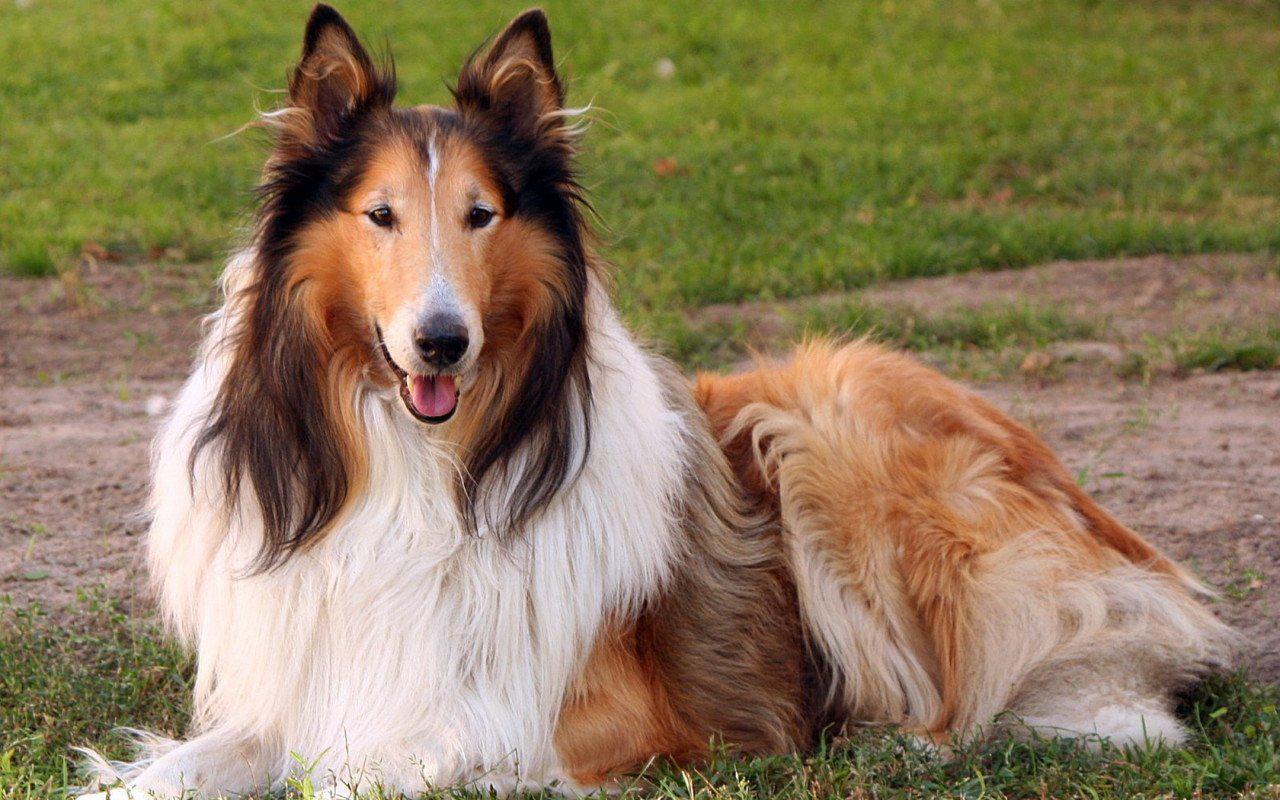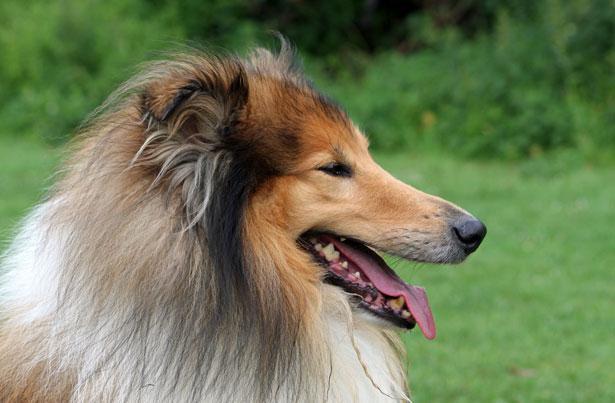The first image is the image on the left, the second image is the image on the right. Evaluate the accuracy of this statement regarding the images: "The dog in the image on the left is looking toward the camera.". Is it true? Answer yes or no. Yes. 